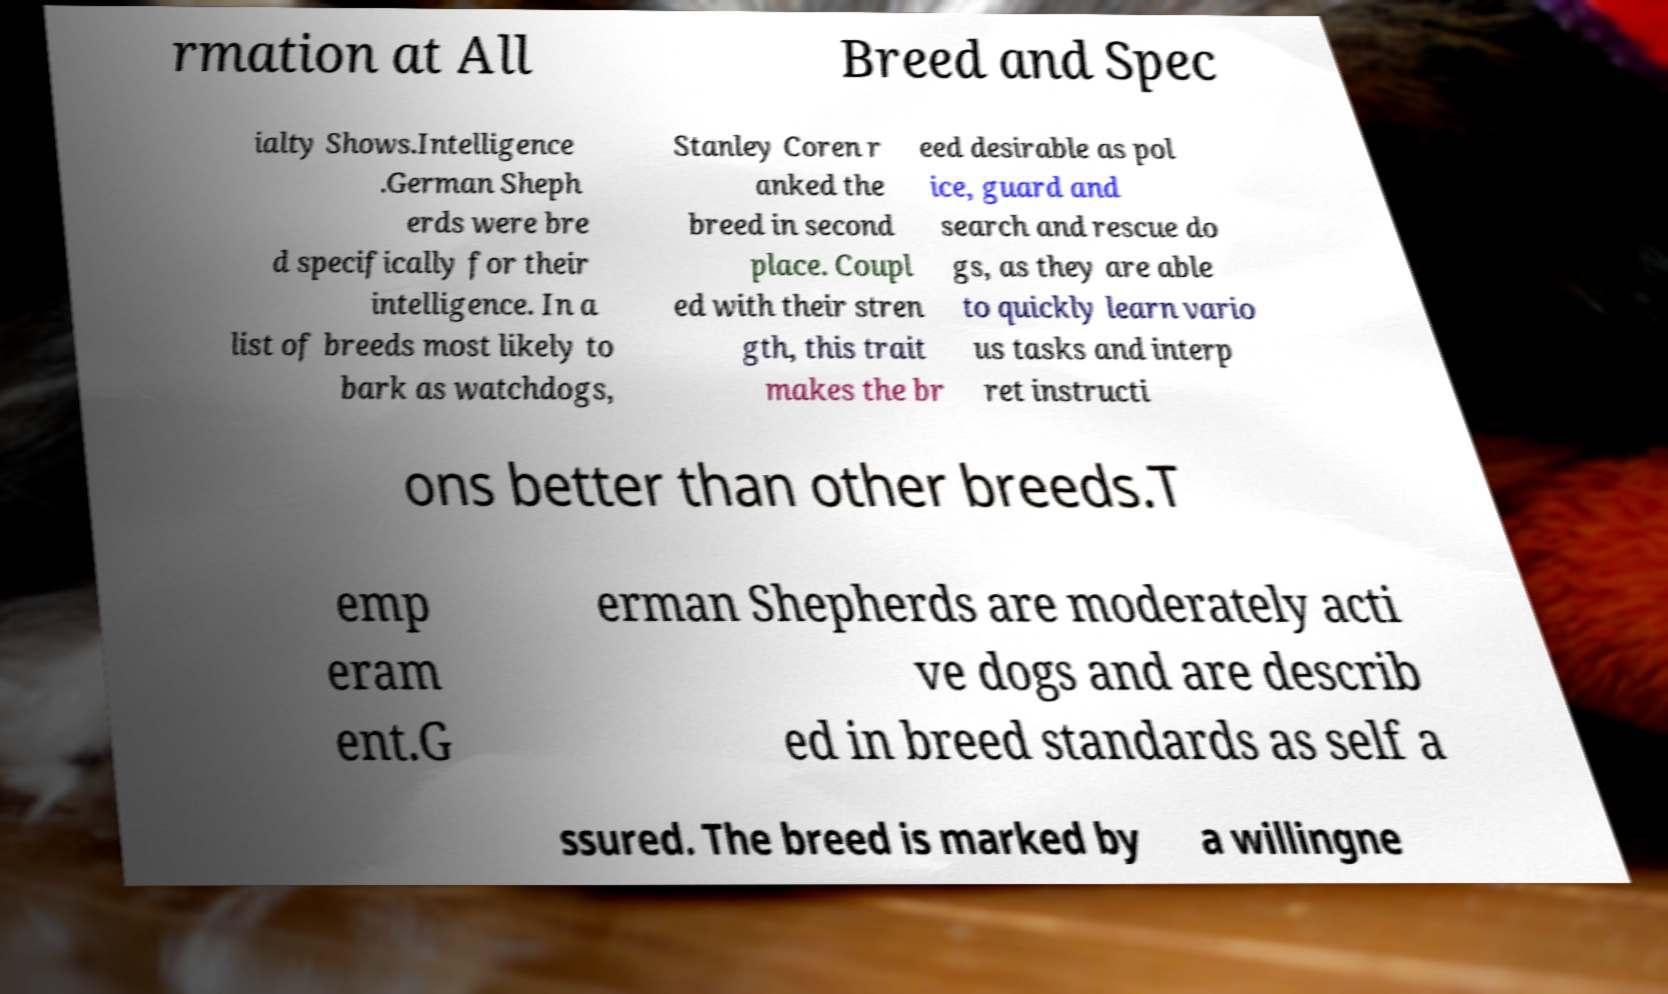Please read and relay the text visible in this image. What does it say? rmation at All Breed and Spec ialty Shows.Intelligence .German Sheph erds were bre d specifically for their intelligence. In a list of breeds most likely to bark as watchdogs, Stanley Coren r anked the breed in second place. Coupl ed with their stren gth, this trait makes the br eed desirable as pol ice, guard and search and rescue do gs, as they are able to quickly learn vario us tasks and interp ret instructi ons better than other breeds.T emp eram ent.G erman Shepherds are moderately acti ve dogs and are describ ed in breed standards as self a ssured. The breed is marked by a willingne 